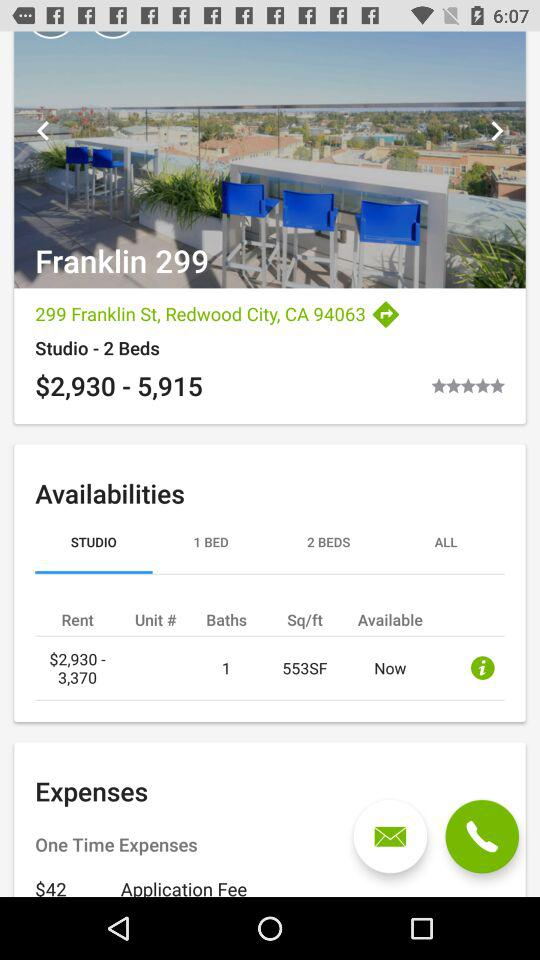What is the application fee? The application fee is $42. 